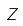<formula> <loc_0><loc_0><loc_500><loc_500>Z</formula> 